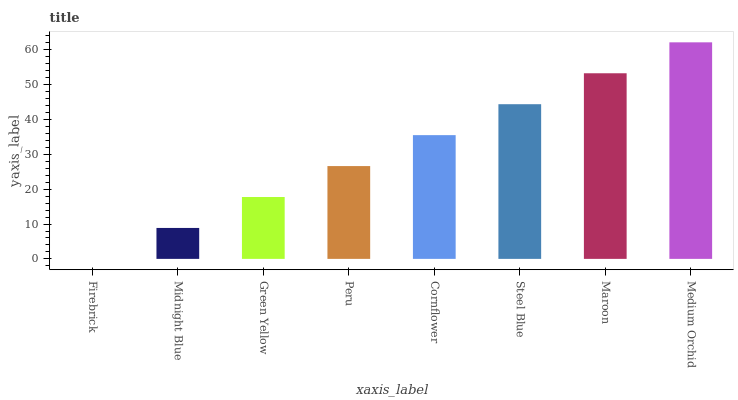Is Firebrick the minimum?
Answer yes or no. Yes. Is Medium Orchid the maximum?
Answer yes or no. Yes. Is Midnight Blue the minimum?
Answer yes or no. No. Is Midnight Blue the maximum?
Answer yes or no. No. Is Midnight Blue greater than Firebrick?
Answer yes or no. Yes. Is Firebrick less than Midnight Blue?
Answer yes or no. Yes. Is Firebrick greater than Midnight Blue?
Answer yes or no. No. Is Midnight Blue less than Firebrick?
Answer yes or no. No. Is Cornflower the high median?
Answer yes or no. Yes. Is Peru the low median?
Answer yes or no. Yes. Is Maroon the high median?
Answer yes or no. No. Is Medium Orchid the low median?
Answer yes or no. No. 